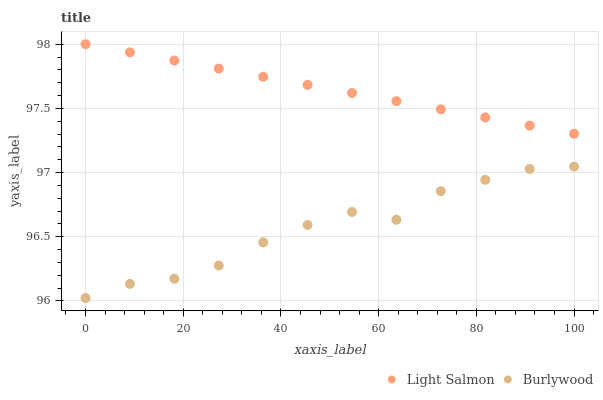Does Burlywood have the minimum area under the curve?
Answer yes or no. Yes. Does Light Salmon have the maximum area under the curve?
Answer yes or no. Yes. Does Light Salmon have the minimum area under the curve?
Answer yes or no. No. Is Light Salmon the smoothest?
Answer yes or no. Yes. Is Burlywood the roughest?
Answer yes or no. Yes. Is Light Salmon the roughest?
Answer yes or no. No. Does Burlywood have the lowest value?
Answer yes or no. Yes. Does Light Salmon have the lowest value?
Answer yes or no. No. Does Light Salmon have the highest value?
Answer yes or no. Yes. Is Burlywood less than Light Salmon?
Answer yes or no. Yes. Is Light Salmon greater than Burlywood?
Answer yes or no. Yes. Does Burlywood intersect Light Salmon?
Answer yes or no. No. 